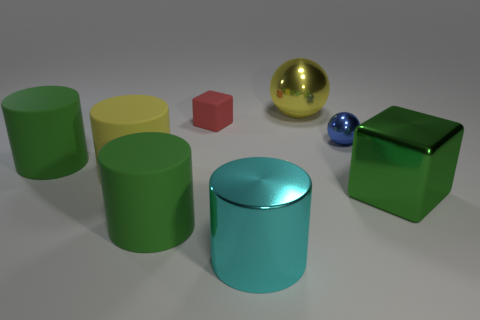Add 2 small blue shiny objects. How many objects exist? 10 Subtract 0 gray spheres. How many objects are left? 8 Subtract all small blue metal objects. Subtract all small yellow matte cubes. How many objects are left? 7 Add 6 big metallic cylinders. How many big metallic cylinders are left? 7 Add 1 small matte things. How many small matte things exist? 2 